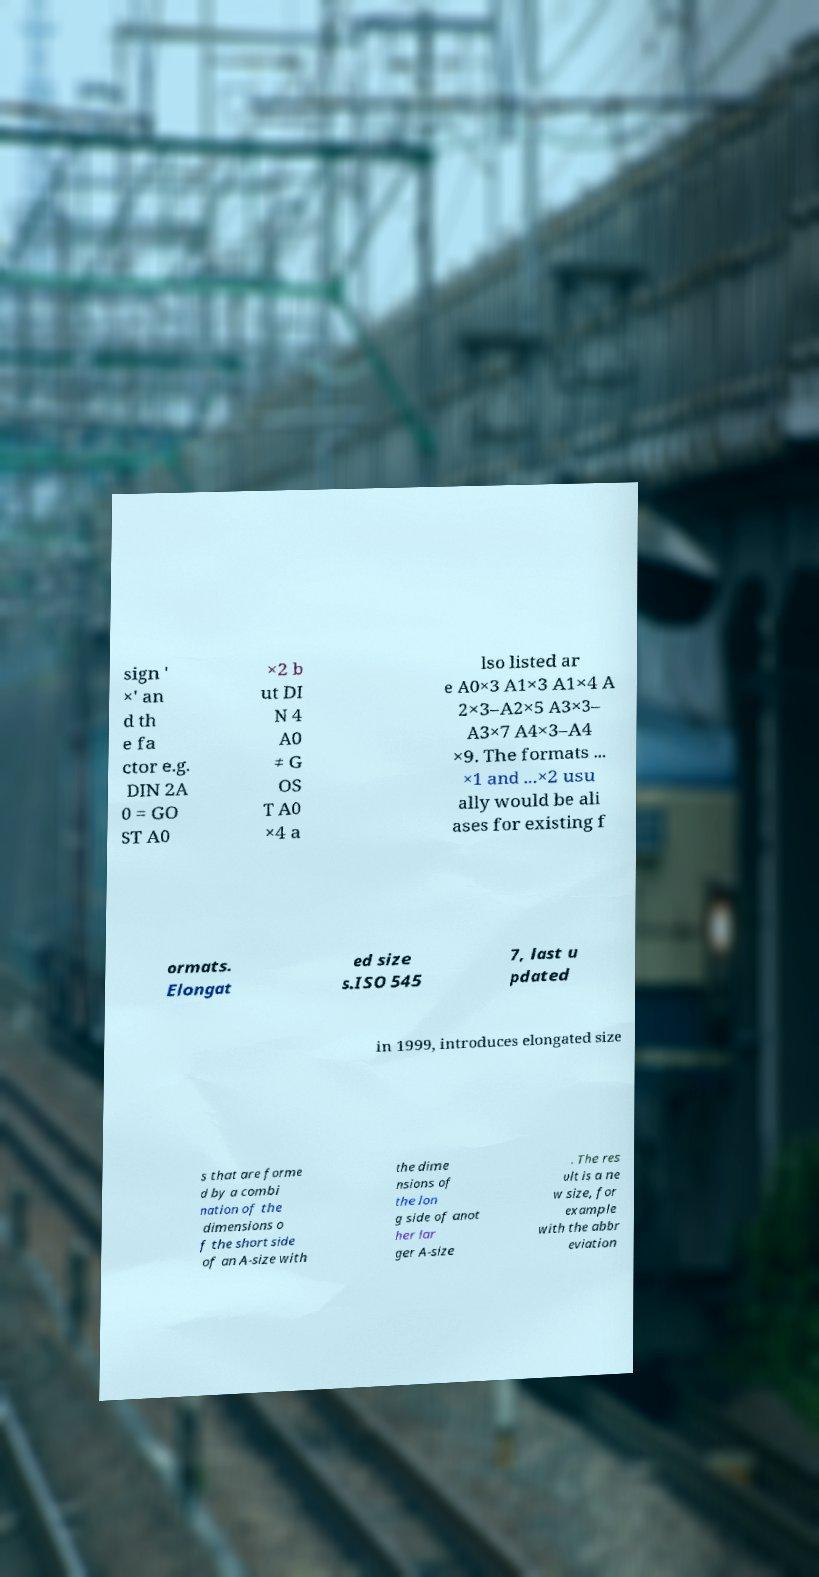I need the written content from this picture converted into text. Can you do that? sign ' ×' an d th e fa ctor e.g. DIN 2A 0 = GO ST A0 ×2 b ut DI N 4 A0 ≠ G OS T A0 ×4 a lso listed ar e A0×3 A1×3 A1×4 A 2×3–A2×5 A3×3– A3×7 A4×3–A4 ×9. The formats ... ×1 and ...×2 usu ally would be ali ases for existing f ormats. Elongat ed size s.ISO 545 7, last u pdated in 1999, introduces elongated size s that are forme d by a combi nation of the dimensions o f the short side of an A-size with the dime nsions of the lon g side of anot her lar ger A-size . The res ult is a ne w size, for example with the abbr eviation 